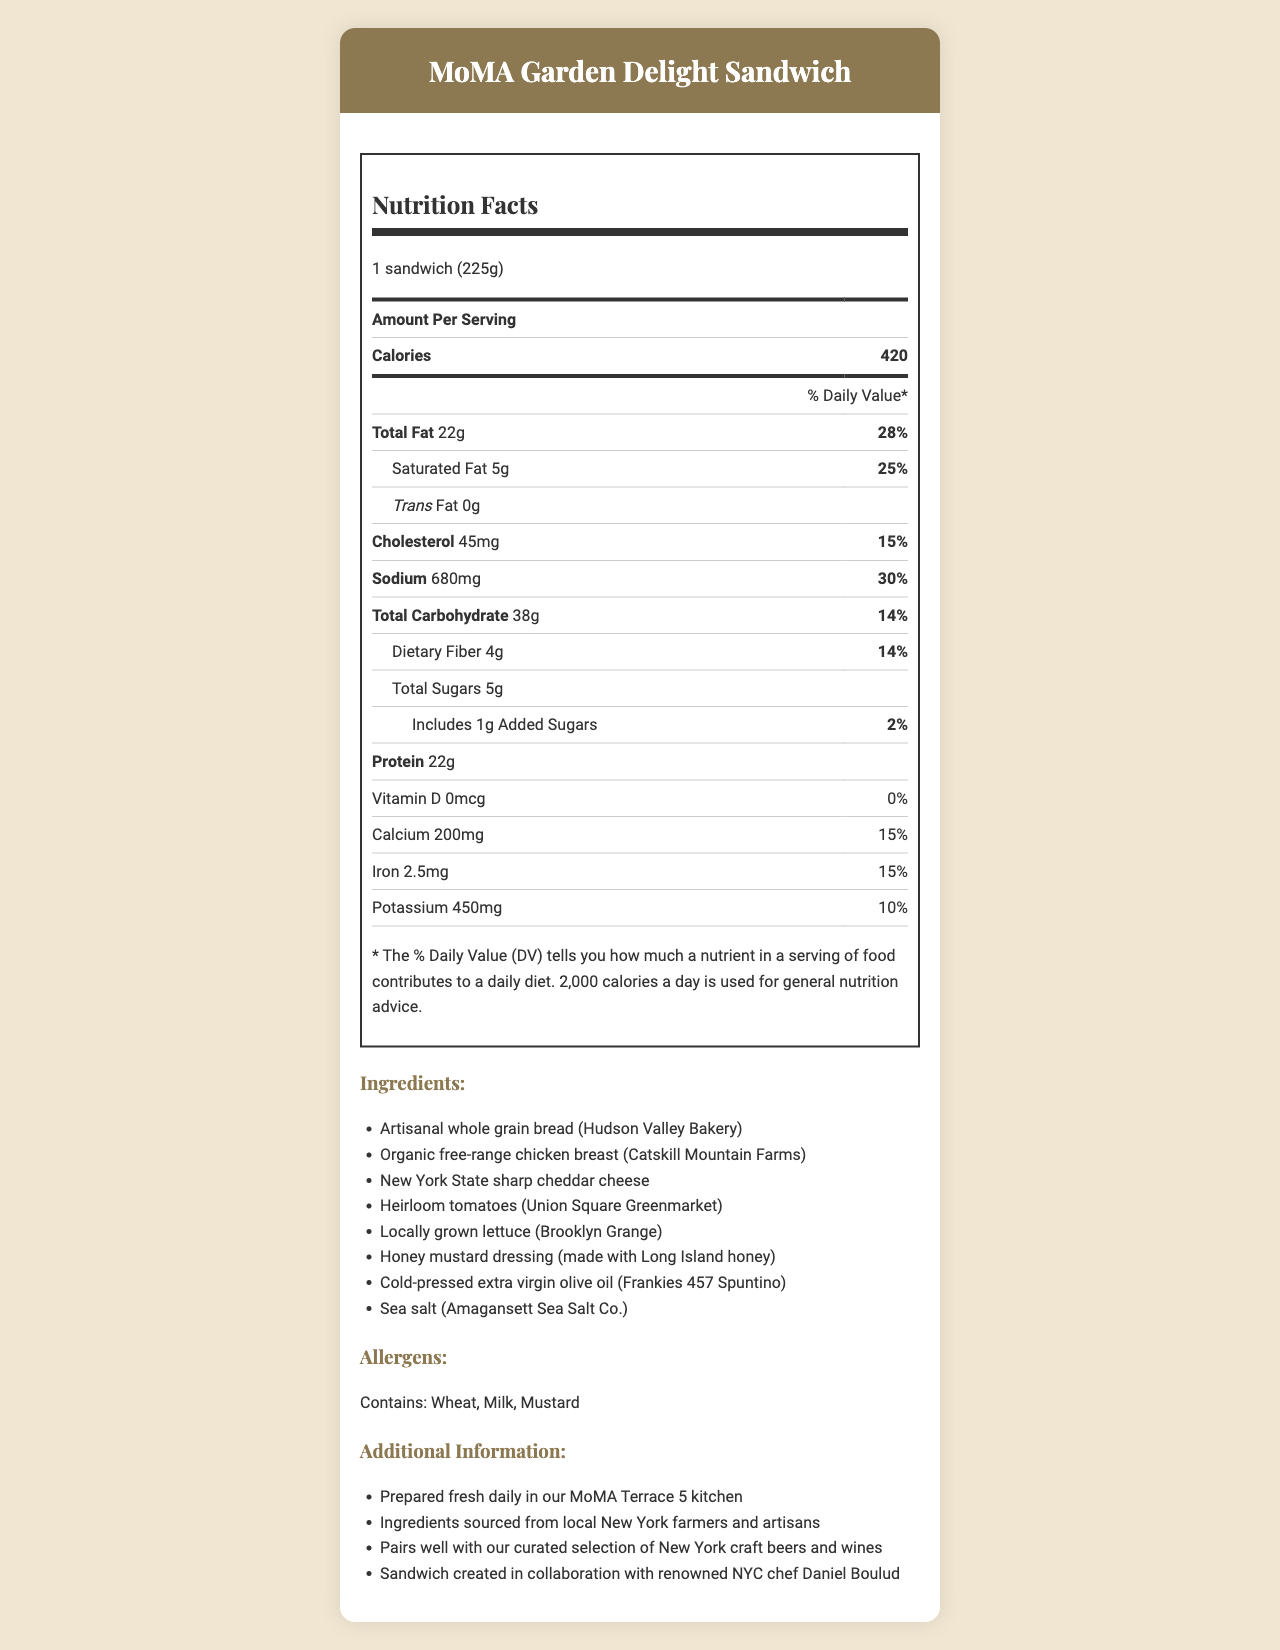what is the serving size of the MoMA Garden Delight Sandwich? The serving size is directly stated under the header "Serving Size" as "1 sandwich (225g)".
Answer: 1 sandwich (225g) how many calories are in the MoMA Garden Delight Sandwich? The number of calories is listed next to the "Calories" label as "420".
Answer: 420 what percentage of the daily value of total fat does the sandwich contain? The total fat amount and its daily value percentage are detailed as 22g and 28% respectively.
Answer: 28% how much sodium does the sandwich have? The sodium content is listed as "680mg" with a daily value percentage of "30%".
Answer: 680mg Which farmer supplies the chicken for the sandwich? One of the listed ingredients specifies that the chicken breast is sourced from "Catskill Mountain Farms".
Answer: Catskill Mountain Farms Does the sandwich contain any allergens? If so, what are they? The allergens section at the bottom clearly states "Contains: Wheat, Milk, Mustard".
Answer: Yes, it contains wheat, milk, and mustard. What is the protein content of the sandwich? The protein content is listed as "22g" next to the "Protein" label.
Answer: 22g Which ingredient is used for the sandwich's dressing? A. Mayonnaise B. Honey mustard C. Ranch The ingredients list specifies "Honey mustard dressing (made with Long Island honey)".
Answer: B. Honey mustard What type of bread is used in the sandwich? A. Sourdough B. Whole grain C. White bread The ingredients list mentions "Artisanal whole grain bread (Hudson Valley Bakery)".
Answer: B. Whole grain Does the sandwich contain any trans fat? The document lists "Trans Fat 0g" indicating that there are no trans fats in the sandwich.
Answer: No Who collaborated with the museum to create the sandwich? The additional information section states that the sandwich was created in collaboration with renowned NYC chef Daniel Boulud.
Answer: Chef Daniel Boulud Does the sandwich pair well with New York craft beers and wines? The additional information section includes a point stating that the sandwich pairs well with the museum's curated selection of New York craft beers and wines.
Answer: Yes How is the sandwich prepared daily? The additional information section notes that the sandwich is "Prepared fresh daily in our MoMA Terrace 5 kitchen".
Answer: Prepared fresh daily in the MoMA Terrace 5 kitchen What nutrient does the sandwich contain the least of? The vitamin D content is 0mcg and 0% daily value, making it the nutrient with the least amount in the sandwich.
Answer: Vitamin D Summarize the document in your own words. The summary covers the main points of the document content: nutrition facts, ingredients' local origins, allergen information, preparation details, and additional notes on sourcing and pairings.
Answer: The document provides detailed nutrition facts for the MoMA Garden Delight Sandwich, featuring locally sourced ingredients. It lists the serving size, calorie count, and other nutritional elements like fats, cholesterol, sodium, carbohydrates, sugars, and proteins. The ingredients are described as locally sourced from New York farmers and artisans, and the sandwich contains allergens such as wheat, milk, and mustard. Additional information highlights the sandwich's daily preparation, local sourcing, pairing recommendation with craft beers and wines, and collaboration with Chef Daniel Boulud. What is the total nutritional content in terms of carbohydrates and proteins combined? Adding the total carbohydrate content (38g) and protein content (22g) provides a combined total of 60g.
Answer: 60g How much dietary fiber is in the sandwich? A. 3g B. 4g C. 5g D. 6g The nutrition facts list the dietary fiber content as 4g.
Answer: B. 4g What brand of sea salt is used in the sandwich? The ingredients list includes "Sea salt (Amagansett Sea Salt Co.)".
Answer: Amagansett Sea Salt Co. Is the sodium content of the sandwich within the recommended daily intake? The sodium content is 680mg, which is 30% of the daily value. Consuming this sandwich alone provides nearly a third of the recommended daily sodium limit.
Answer: No How long does it take to prepare the sandwich? The document highlights that the sandwich is prepared fresh daily but does not specify the preparation time.
Answer: Not enough information 